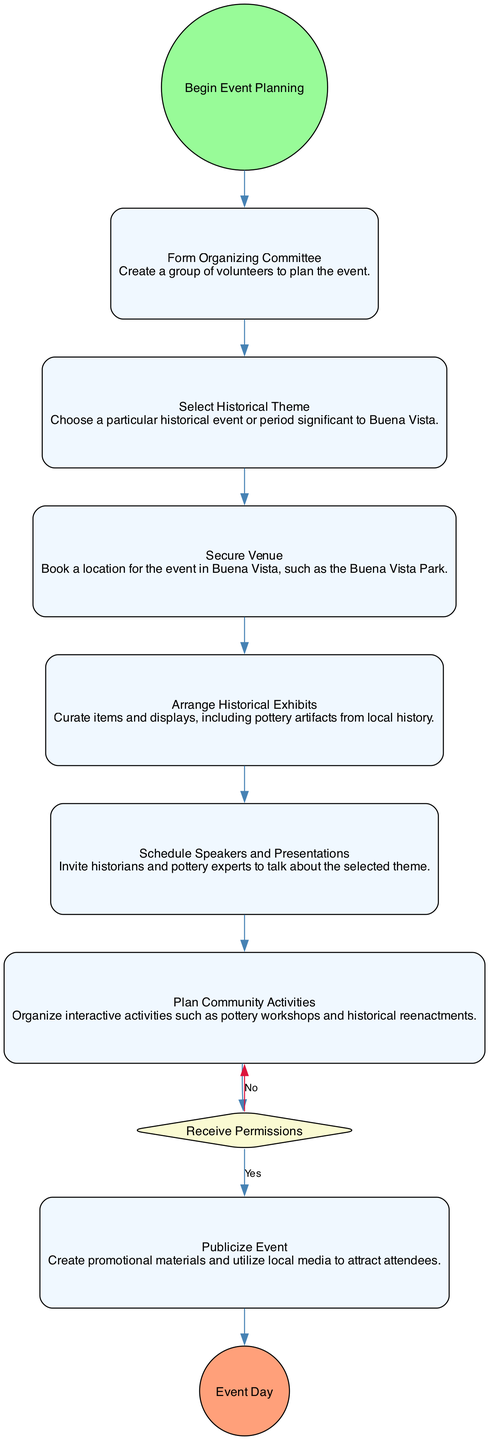What is the first activity in the diagram? The first node after the StartEvent is "Form Organizing Committee" which indicates the initial step in the planning process.
Answer: Form Organizing Committee How many activities are there in the diagram? Counting all nodes that are activities, there are 6 activities identified in the diagram.
Answer: 6 What is the final event in the diagram? The last node present in the diagram after all activities is "Event Day," marking the conclusion of the planning process.
Answer: Event Day What comes after "Select Historical Theme"? The activity that follows "Select Historical Theme" is "Secure Venue." This indicates the flow from selecting the theme to securing a location for the event.
Answer: Secure Venue What decision needs to be made before "Publicize Event"? The decision that must be made before proceeding to "Publicize Event" is to "Receive Permissions," which involves contacting local authorities for approvals.
Answer: Receive Permissions How many nodes represent decisions in the diagram? In the diagram, there is one decision node labeled "Receive Permissions." It's the only decision point impacting the flow of activities.
Answer: 1 Which activity involves experts? The activity "Schedule Speakers and Presentations" specifically mentions inviting historians and pottery experts to speak, highlighting expertise involvement.
Answer: Schedule Speakers and Presentations What are community activities planned? The activity "Plan Community Activities" refers to organizing interactive events like pottery workshops and historical reenactments, which are the community activities planned.
Answer: Plan Community Activities In what shape is the "StartEvent" represented? The "StartEvent" is represented as a circle, indicating the beginning of the process in the activity diagram.
Answer: Circle 